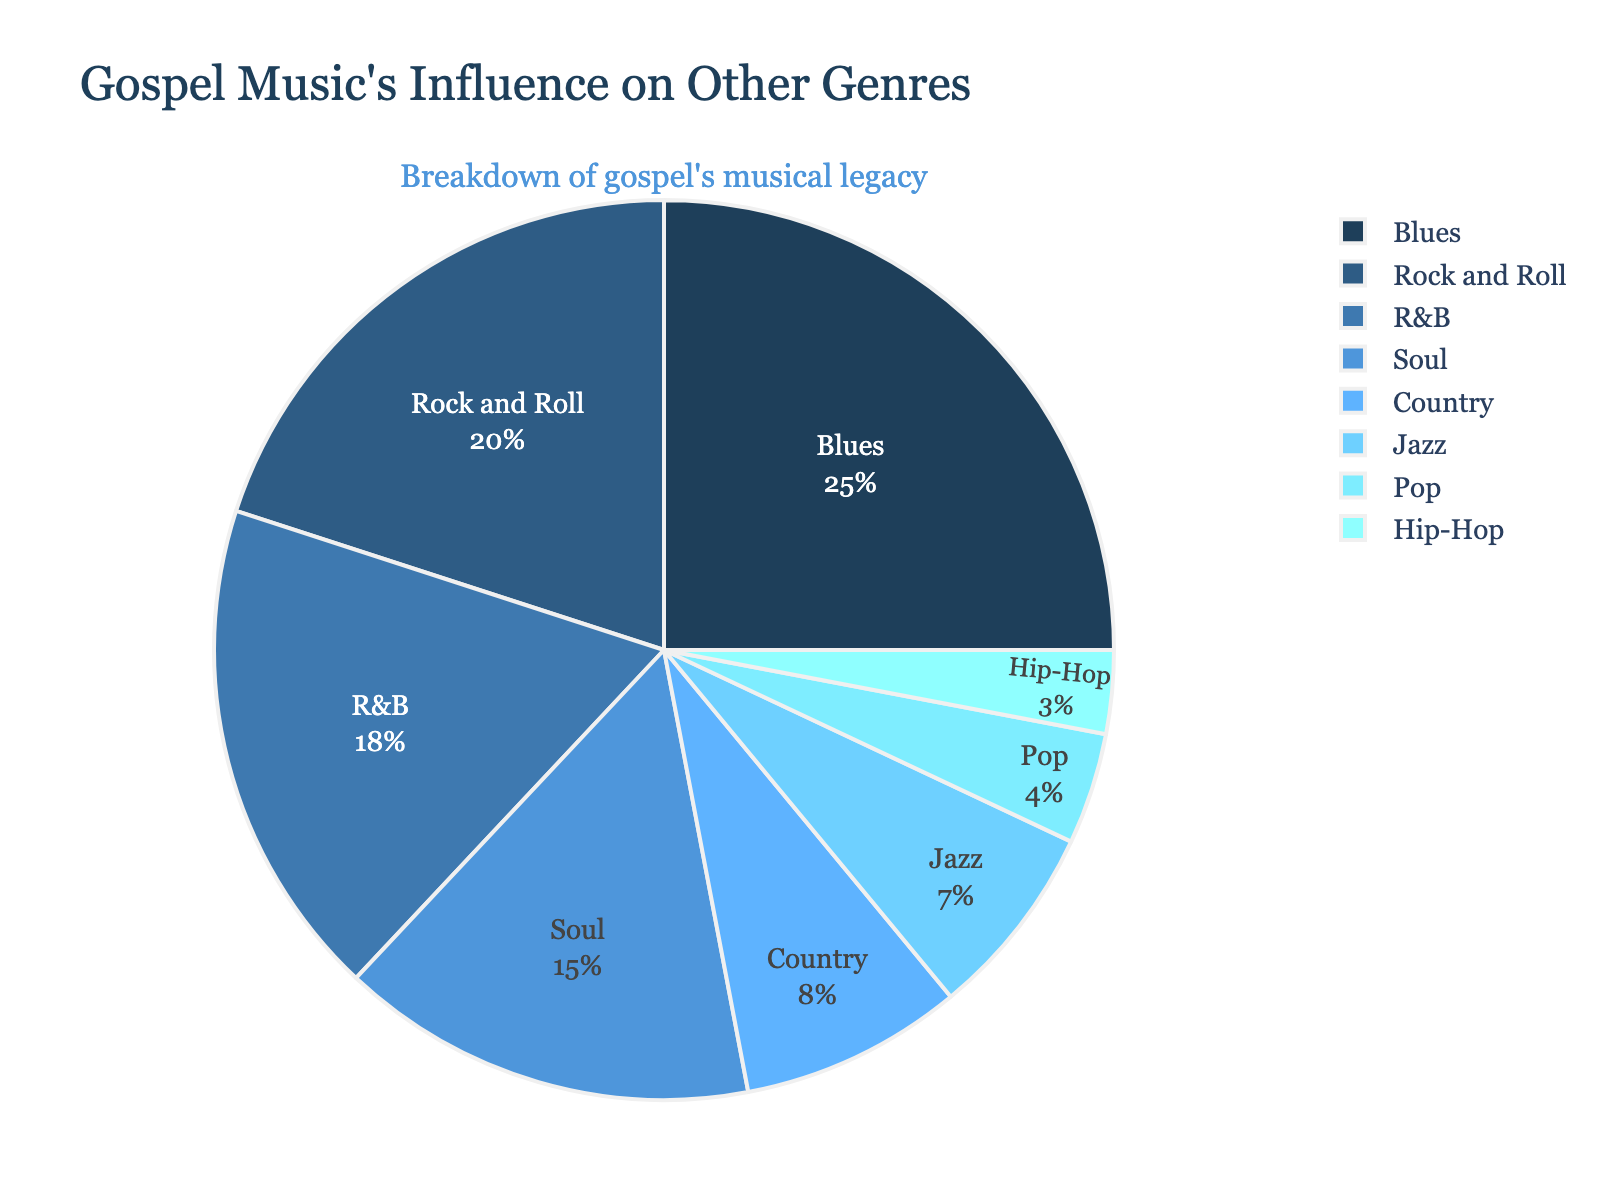Which genre has the largest influence according to the figure? The figure shows different genres with their respective percentages of influence stemming from gospel music. The largest segment belongs to Blues at 25%.
Answer: Blues Which genre has a smaller influence: R&B or Jazz? The figure shows that R&B has an influence percentage of 18%, while Jazz has an influence percentage of 7%. Since 7% is less than 18%, Jazz has a smaller influence.
Answer: Jazz What is the combined influence percentage of Blues and Rock and Roll? The influence percentage of Blues is 25% and Rock and Roll is 20%. Adding these together, 25% + 20% = 45%.
Answer: 45% Which genre has the least influence from gospel music? By looking at the smallest segment in the figure, it's clear that Hip-Hop has the smallest influence percentage at 3%.
Answer: Hip-Hop How much more influence does Soul have over Country? The influence percentage for Soul is 15%, and for Country, it is 8%. Subtracting these, 15% - 8% = 7%.
Answer: 7% What is the combined influence percentage of the genres with less than 10% influence from gospel music? The genres with less than 10% influence are Country (8%), Jazz (7%), Pop (4%), and Hip-Hop (3%). Adding these, 8% + 7% + 4% + 3% = 22%.
Answer: 22% Which genre has a similar influence percentage to Rock and Roll? By examining the segments, Rock and Roll has an influence percentage of 20%. This is closest to R&B, which has an 18% influence.
Answer: R&B What is the difference in influence percentage between the genre with the highest influence and the genre with the second highest influence? The genre with the highest influence is Blues at 25%, and the second highest is Rock and Roll at 20%. The difference is 25% - 20% = 5%.
Answer: 5% Is the combined influence of Soul and R&B greater or less than the influence of Blues alone? Soul has a 15% influence, and R&B has an 18% influence. Combined, 15% + 18% = 33%. Since Blues is 25%, 33% is greater than 25%.
Answer: Greater What is the average influence percentage of Jazz, Pop, and Hip-Hop? The influence percentage for Jazz is 7%, Pop is 4%, and Hip-Hop is 3%. Summing these, 7% + 4% + 3% = 14%. Dividing by the number of genres (3), 14% / 3 = 4.67%.
Answer: 4.67% 